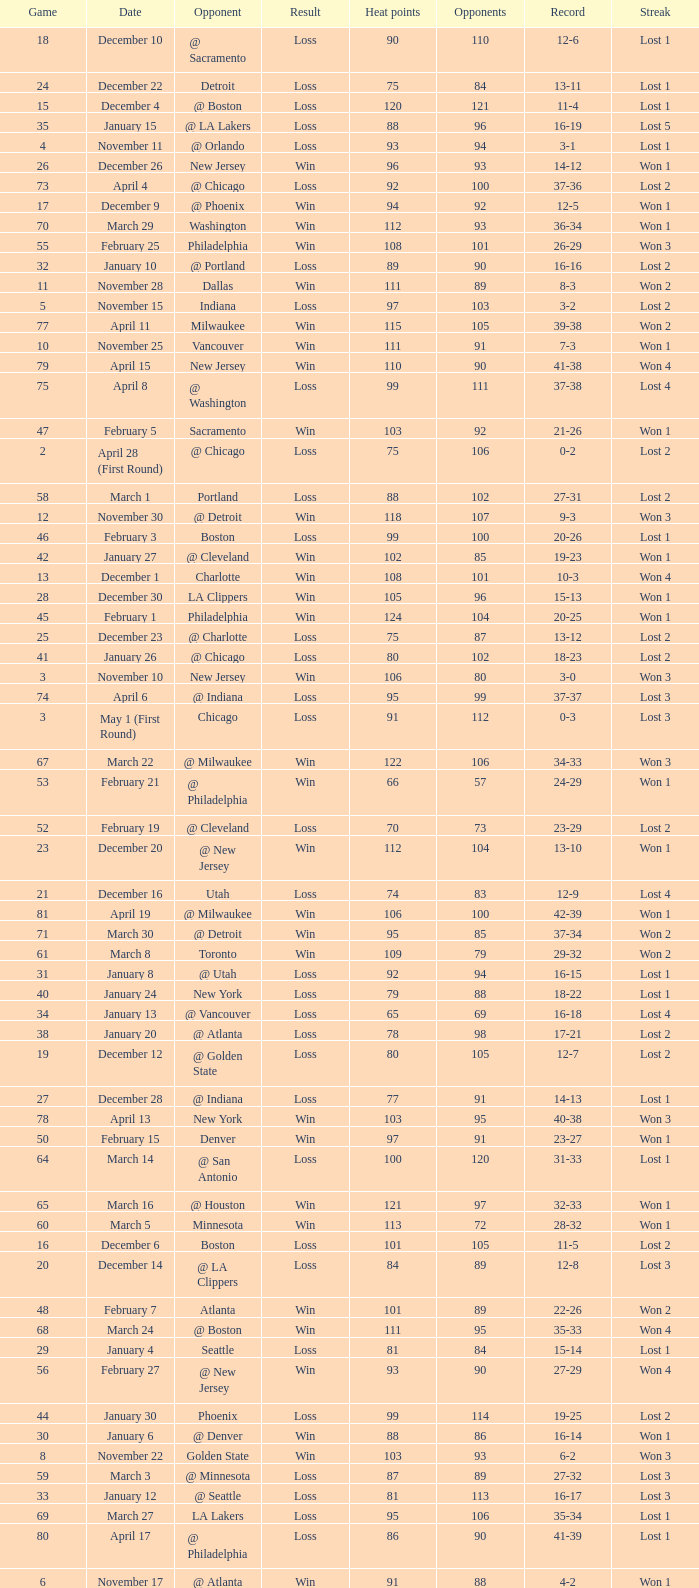What is the highest Game, when Opponents is less than 80, and when Record is "1-0"? 1.0. 